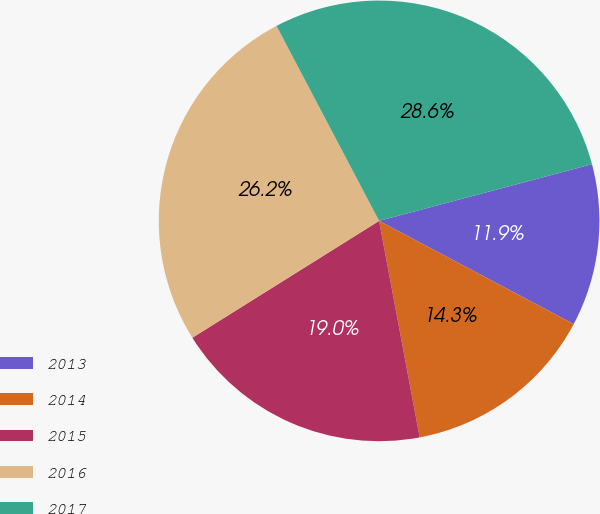<chart> <loc_0><loc_0><loc_500><loc_500><pie_chart><fcel>2013<fcel>2014<fcel>2015<fcel>2016<fcel>2017<nl><fcel>11.9%<fcel>14.29%<fcel>19.05%<fcel>26.19%<fcel>28.57%<nl></chart> 